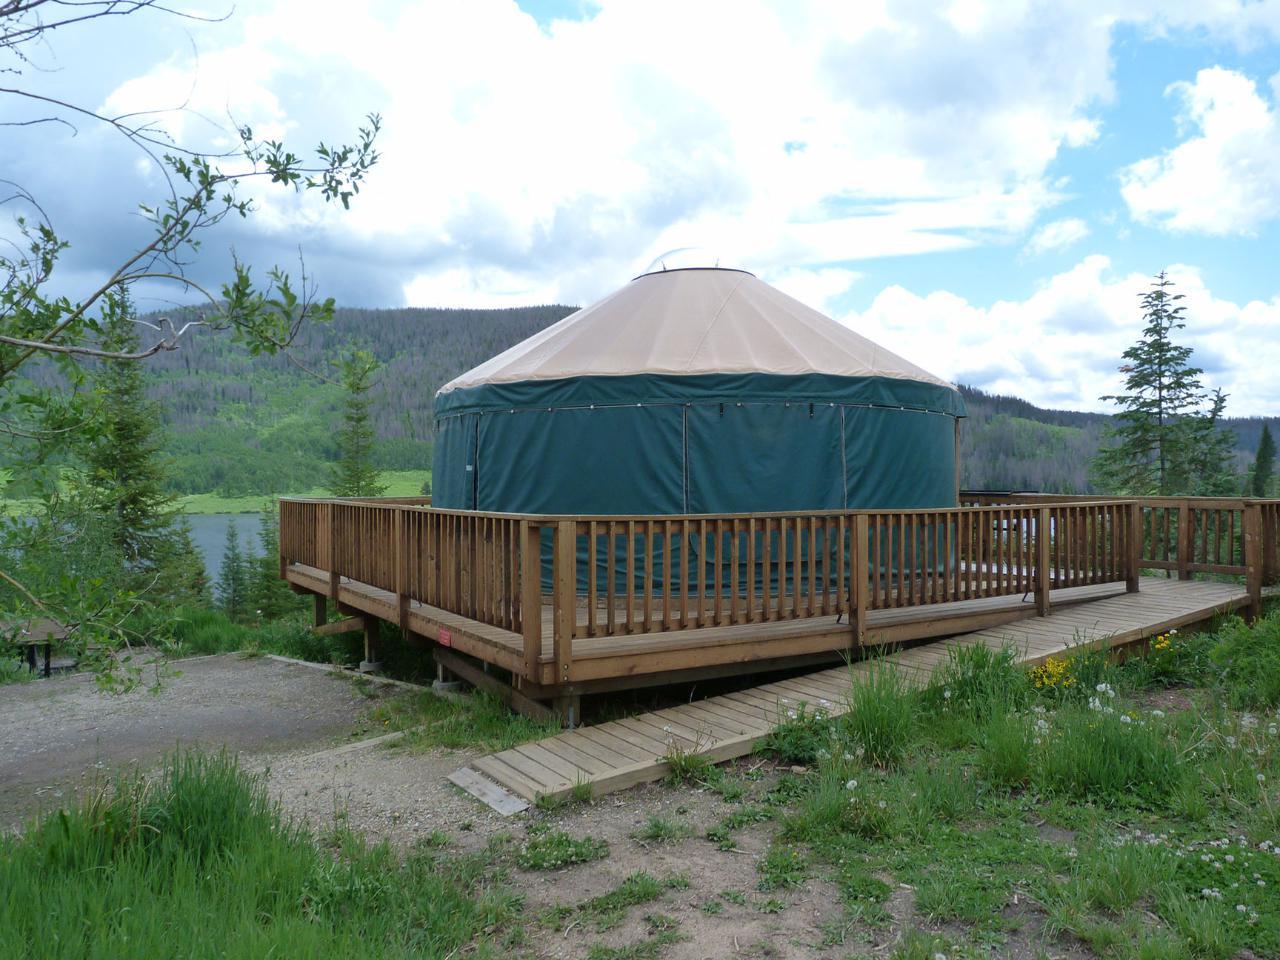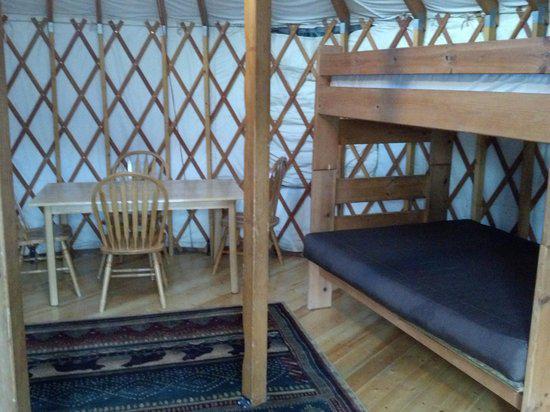The first image is the image on the left, the second image is the image on the right. For the images displayed, is the sentence "All of the images display the interior of the hut." factually correct? Answer yes or no. No. 